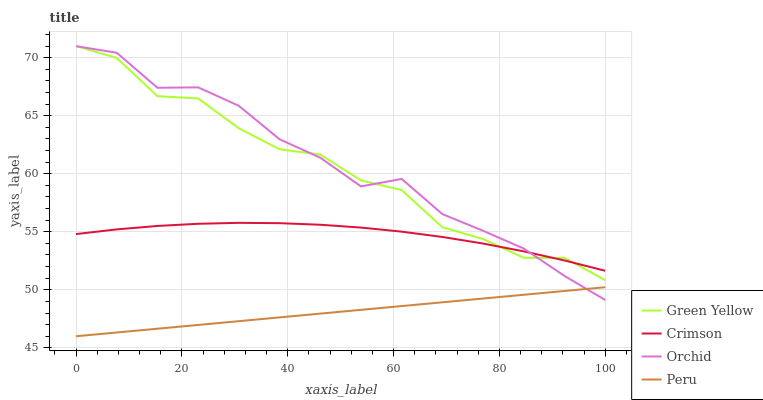Does Peru have the minimum area under the curve?
Answer yes or no. Yes. Does Orchid have the maximum area under the curve?
Answer yes or no. Yes. Does Green Yellow have the minimum area under the curve?
Answer yes or no. No. Does Green Yellow have the maximum area under the curve?
Answer yes or no. No. Is Peru the smoothest?
Answer yes or no. Yes. Is Green Yellow the roughest?
Answer yes or no. Yes. Is Green Yellow the smoothest?
Answer yes or no. No. Is Peru the roughest?
Answer yes or no. No. Does Peru have the lowest value?
Answer yes or no. Yes. Does Green Yellow have the lowest value?
Answer yes or no. No. Does Green Yellow have the highest value?
Answer yes or no. Yes. Does Peru have the highest value?
Answer yes or no. No. Is Peru less than Green Yellow?
Answer yes or no. Yes. Is Green Yellow greater than Peru?
Answer yes or no. Yes. Does Orchid intersect Peru?
Answer yes or no. Yes. Is Orchid less than Peru?
Answer yes or no. No. Is Orchid greater than Peru?
Answer yes or no. No. Does Peru intersect Green Yellow?
Answer yes or no. No. 